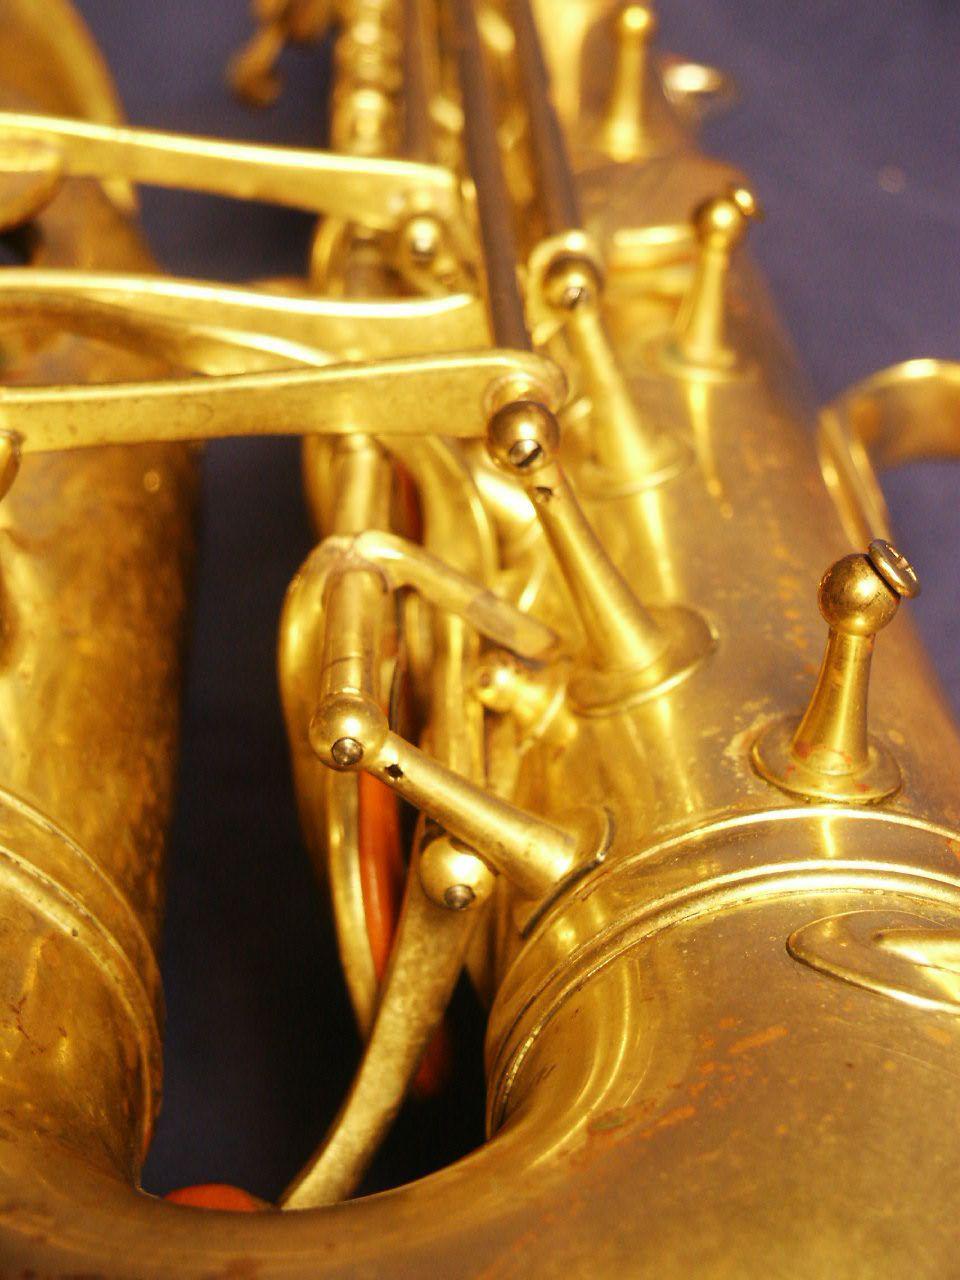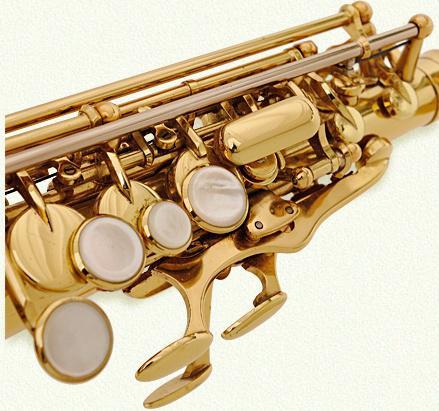The first image is the image on the left, the second image is the image on the right. Assess this claim about the two images: "A section of a brass-colored instrument containing button and lever shapes is displayed on a white background.". Correct or not? Answer yes or no. Yes. 